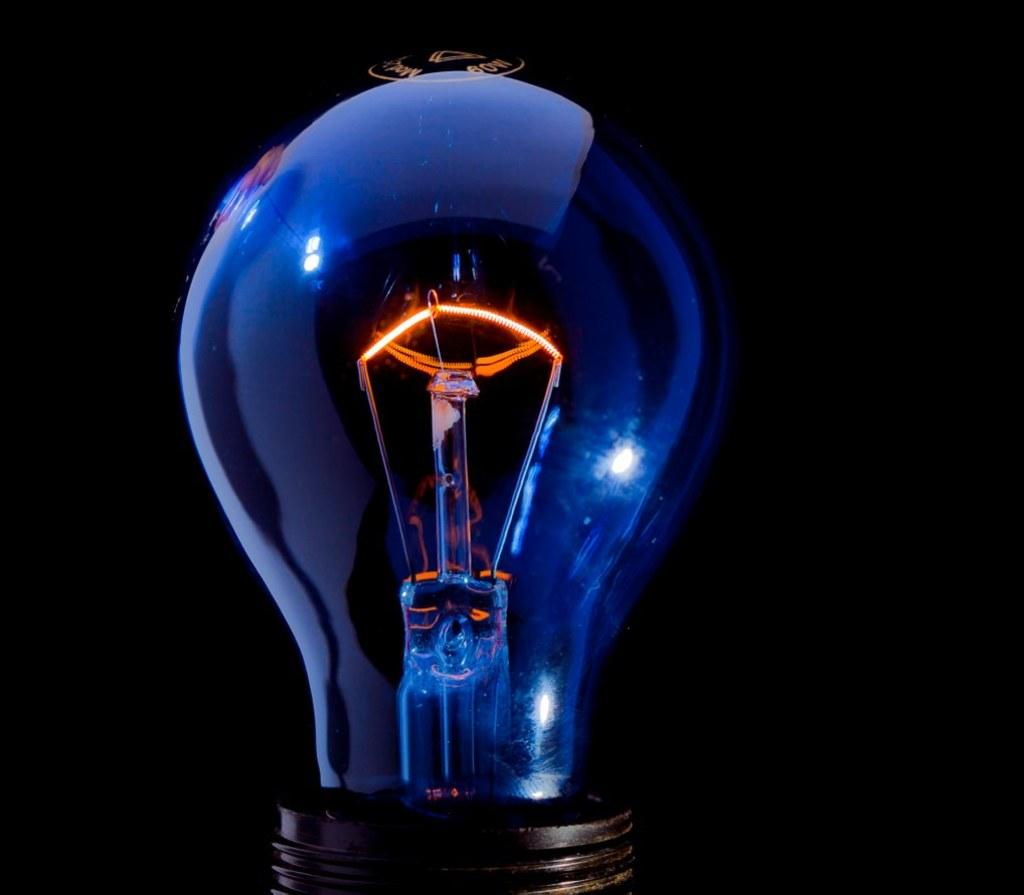What object is present in the image? There is a bulb in the image. What type of door can be seen in the image? There is no door present in the image; it only features a bulb. Is there a key visible in the image? There is no key present in the image; it only features a bulb. 